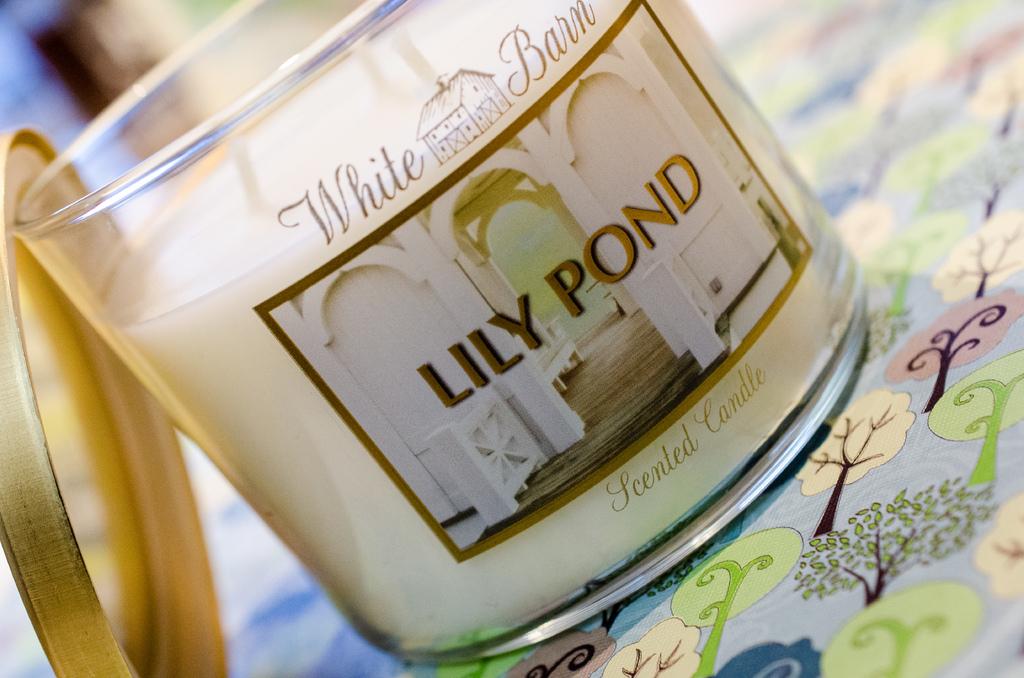What is the scent of the candle?
Your answer should be very brief. Lily pond. What is the brand name shown on the item?
Keep it short and to the point. White barn. 